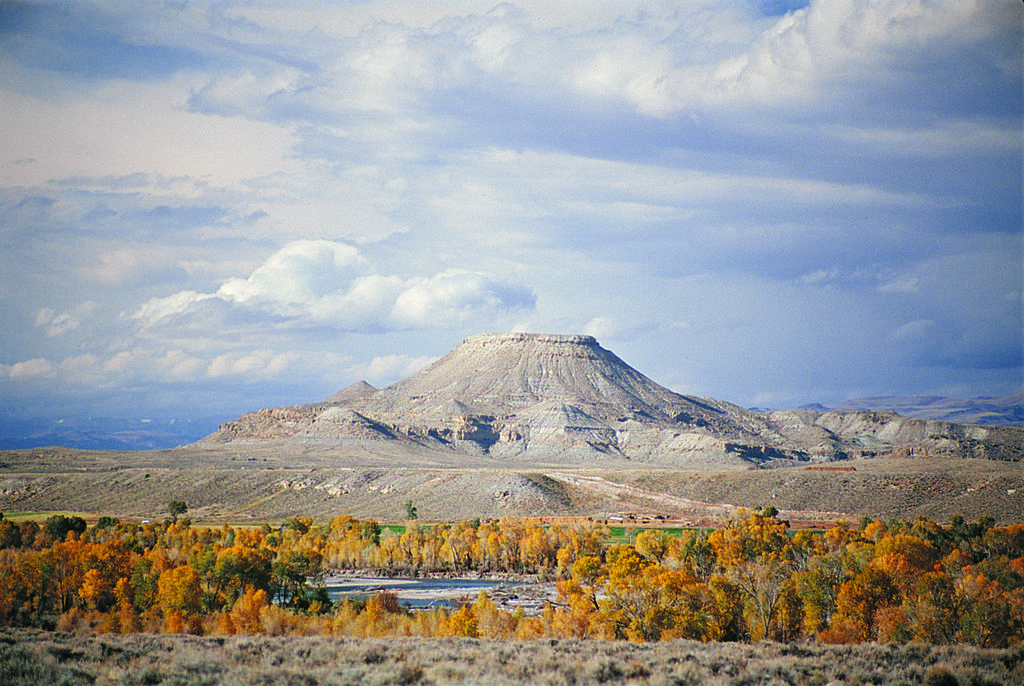What type of natural environment is depicted in the image? The image features trees, water, and mountains, suggesting a natural landscape. Can you describe the water in the image? There is water visible in the image, but its specific characteristics are not mentioned in the facts. What is visible in the background of the image? Mountains are visible in the background of the image. What is the condition of the sky in the image? The sky contains clouds, as mentioned in the facts. What is the caption of the image? There is no caption provided in the facts, so we cannot determine the caption of the image. What is the tendency of the star in the image? There is no star present in the image, so we cannot determine the tendency of a star. 